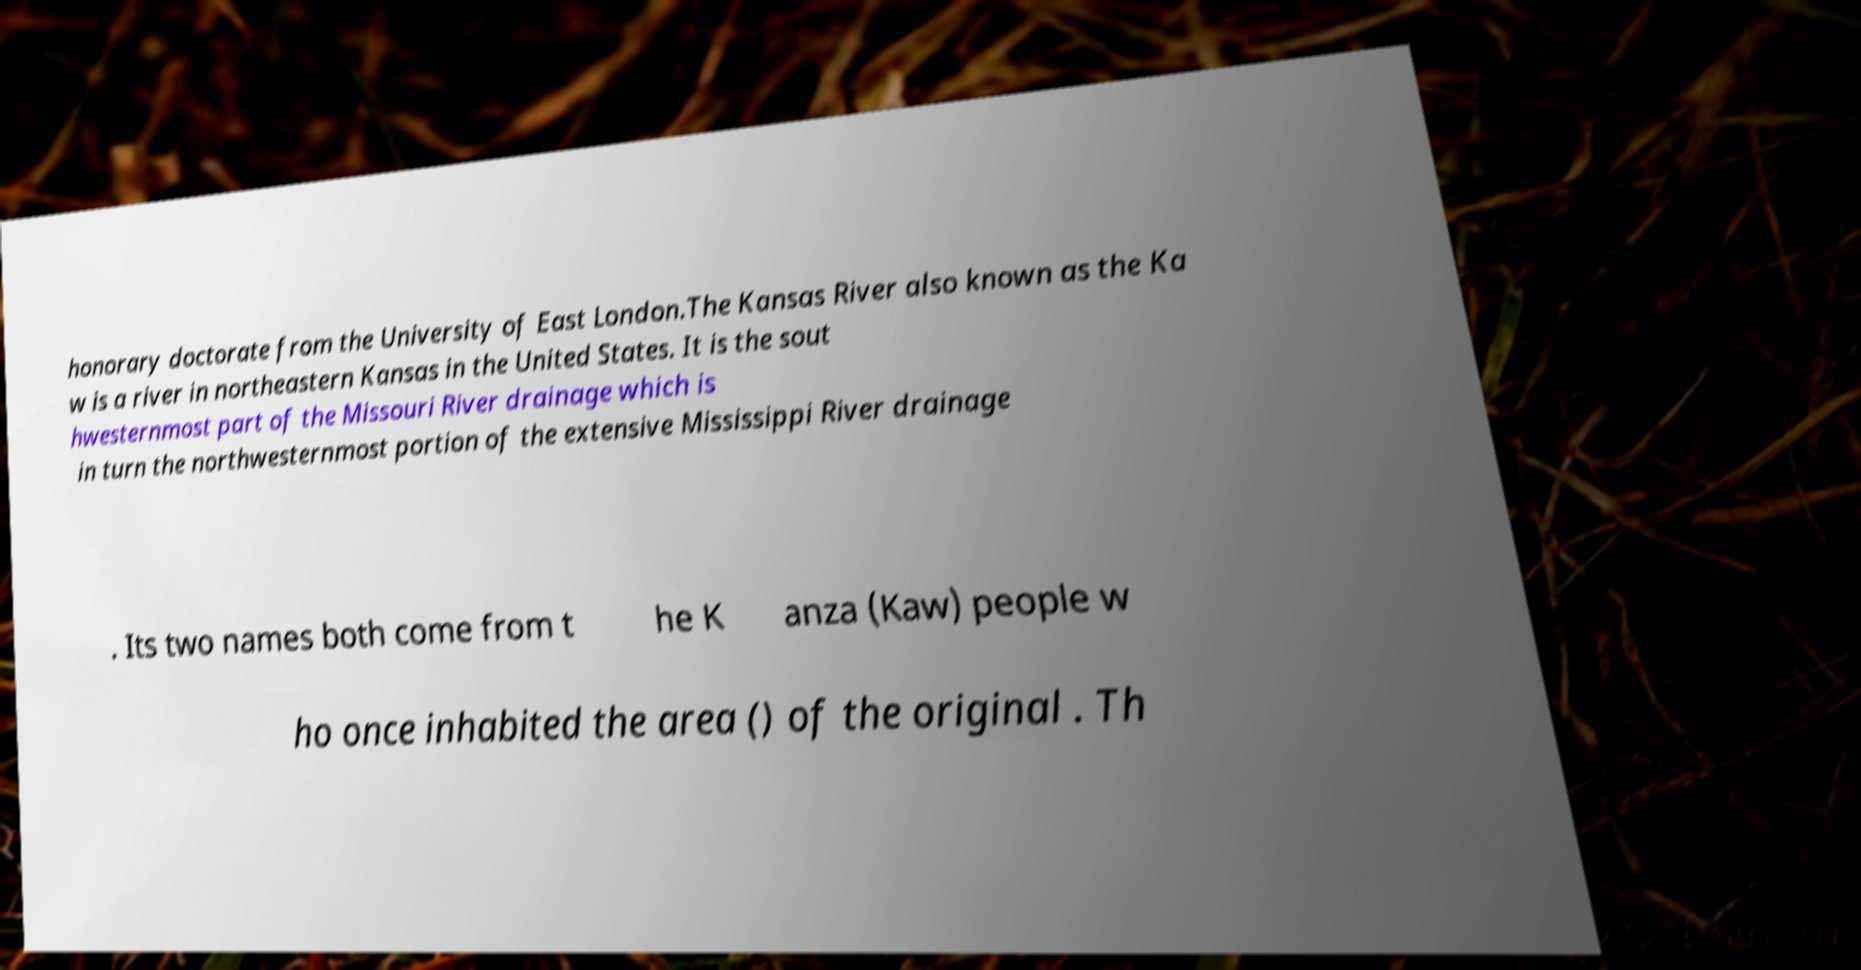Can you read and provide the text displayed in the image?This photo seems to have some interesting text. Can you extract and type it out for me? honorary doctorate from the University of East London.The Kansas River also known as the Ka w is a river in northeastern Kansas in the United States. It is the sout hwesternmost part of the Missouri River drainage which is in turn the northwesternmost portion of the extensive Mississippi River drainage . Its two names both come from t he K anza (Kaw) people w ho once inhabited the area () of the original . Th 